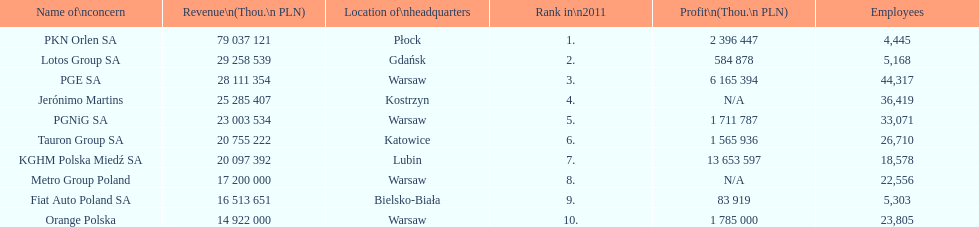What are the names of all the concerns? PKN Orlen SA, Lotos Group SA, PGE SA, Jerónimo Martins, PGNiG SA, Tauron Group SA, KGHM Polska Miedź SA, Metro Group Poland, Fiat Auto Poland SA, Orange Polska. How many employees does pgnig sa have? 33,071. 